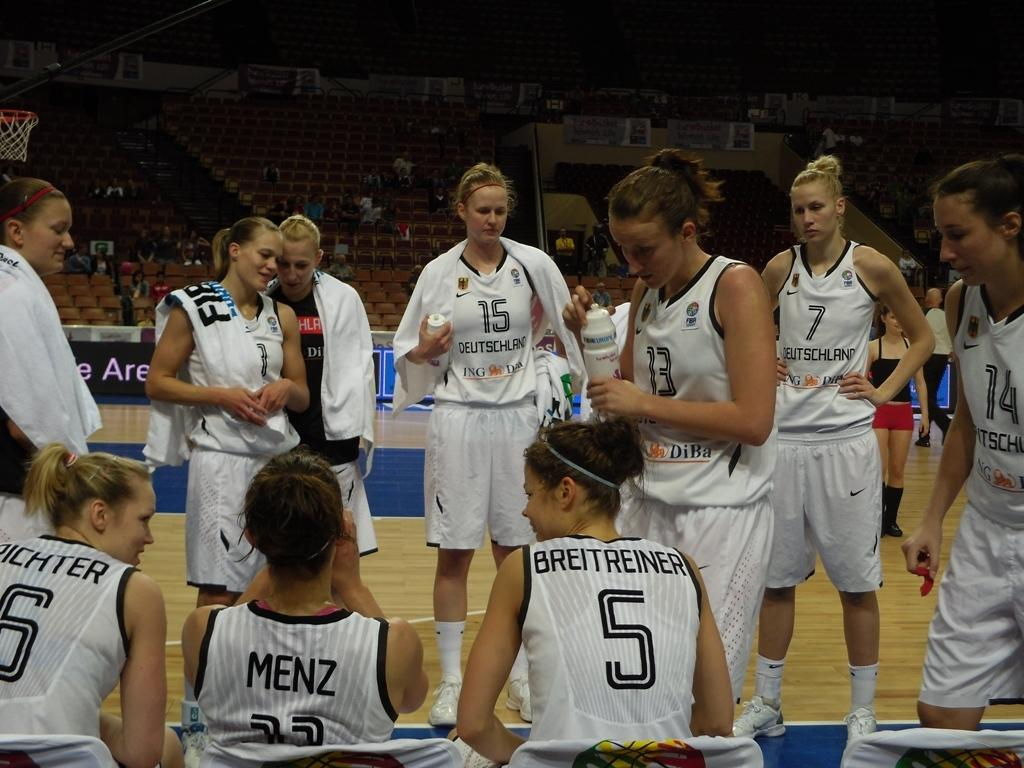<image>
Render a clear and concise summary of the photo. A woman's basketball team on the court from Deutschland 